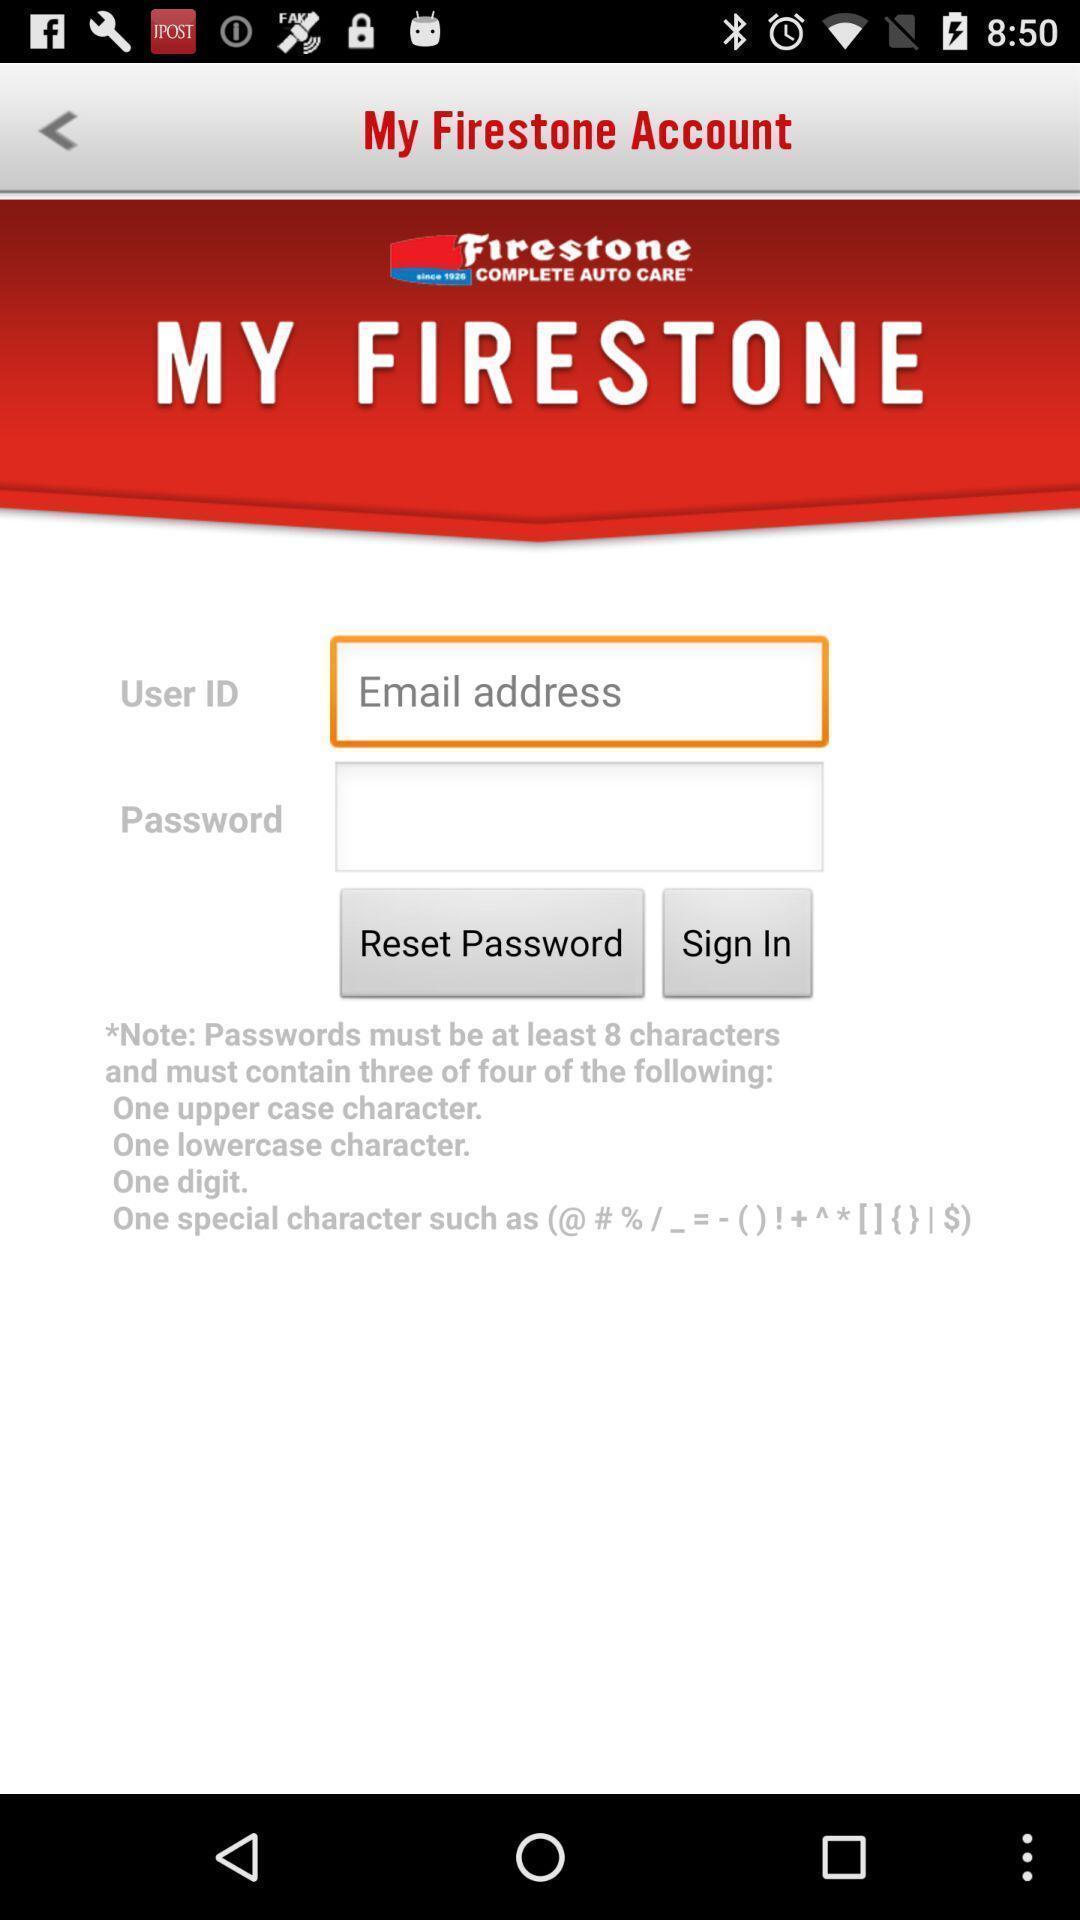Describe the visual elements of this screenshot. Sign in page of vehicle maintenance app. 